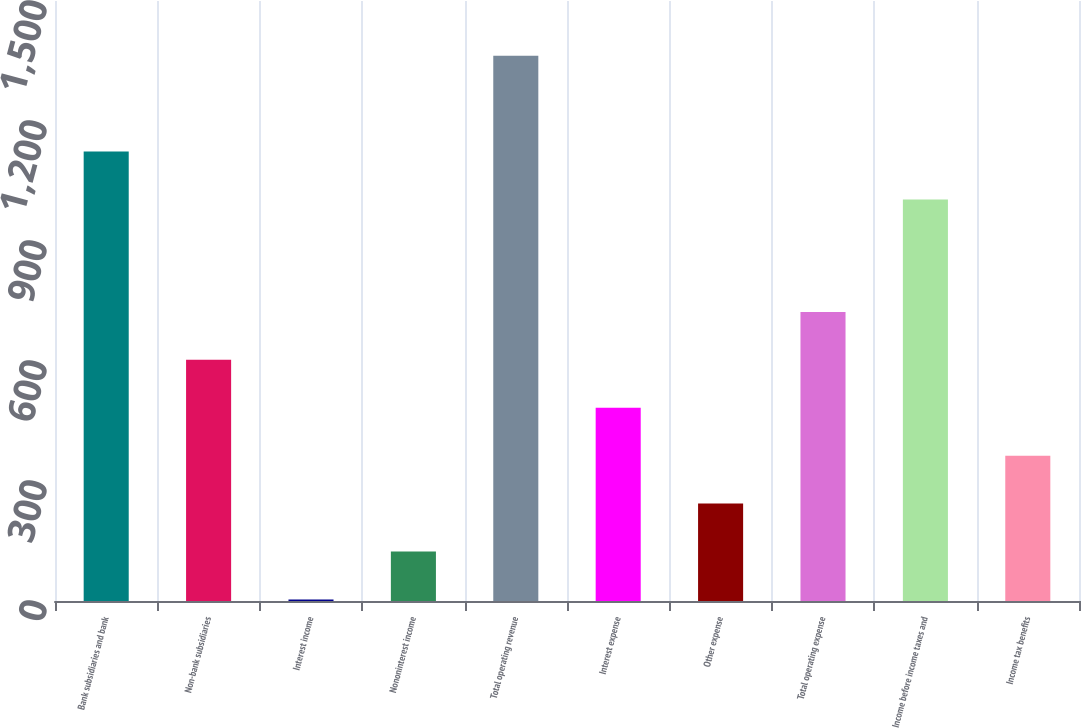Convert chart. <chart><loc_0><loc_0><loc_500><loc_500><bar_chart><fcel>Bank subsidiaries and bank<fcel>Non-bank subsidiaries<fcel>Interest income<fcel>Nononinterest income<fcel>Total operating revenue<fcel>Interest expense<fcel>Other expense<fcel>Total operating expense<fcel>Income before income taxes and<fcel>Income tax benefits<nl><fcel>1123.8<fcel>603<fcel>4<fcel>123.8<fcel>1363.4<fcel>483.2<fcel>243.6<fcel>722.8<fcel>1004<fcel>363.4<nl></chart> 